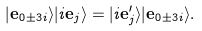<formula> <loc_0><loc_0><loc_500><loc_500>| \mathbf e _ { 0 \pm 3 i } \rangle | i \mathbf e _ { j } \rangle = | i \mathbf e _ { j } ^ { \prime } \rangle | \mathbf e _ { 0 \pm 3 i } \rangle .</formula> 